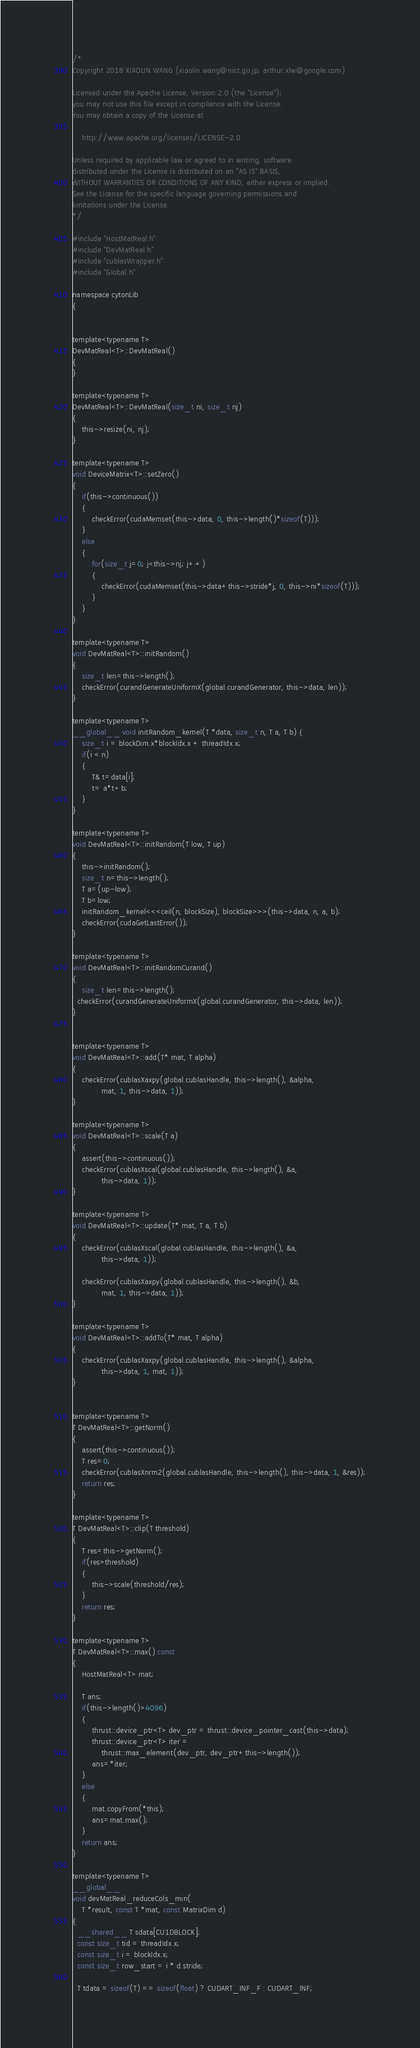<code> <loc_0><loc_0><loc_500><loc_500><_Cuda_>/*
Copyright 2018 XIAOLIN WANG (xiaolin.wang@nict.go.jp; arthur.xlw@google.com)

Licensed under the Apache License, Version 2.0 (the "License");
you may not use this file except in compliance with the License.
You may obtain a copy of the License at

    http://www.apache.org/licenses/LICENSE-2.0

Unless required by applicable law or agreed to in writing, software
distributed under the License is distributed on an "AS IS" BASIS,
WITHOUT WARRANTIES OR CONDITIONS OF ANY KIND, either express or implied.
See the License for the specific language governing permissions and
limitations under the License.
*/

#include "HostMatReal.h"
#include "DevMatReal.h"
#include "cublasWrapper.h"
#include "Global.h"

namespace cytonLib
{


template<typename T>
DevMatReal<T>::DevMatReal()
{
}

template<typename T>
DevMatReal<T>::DevMatReal(size_t ni, size_t nj)
{
	this->resize(ni, nj);
}

template<typename T>
void DeviceMatrix<T>::setZero()
{
	if(this->continuous())
	{
		checkError(cudaMemset(this->data, 0, this->length()*sizeof(T)));
	}
	else
	{
		for(size_t j=0; j<this->nj; j++)
		{
			checkError(cudaMemset(this->data+this->stride*j, 0, this->ni*sizeof(T)));
		}
	}
}

template<typename T>
void DevMatReal<T>::initRandom()
{
	size_t len=this->length();
    checkError(curandGenerateUniformX(global.curandGenerator, this->data, len));
}

template<typename T>
__global__ void initRandom_kernel(T *data, size_t n, T a, T b) {
    size_t i = blockDim.x*blockIdx.x + threadIdx.x;
    if(i < n)
    {
    	T& t=data[i];
    	t= a*t+b;
    }
}

template<typename T>
void DevMatReal<T>::initRandom(T low, T up)
{
	this->initRandom();
	size_t n=this->length();
	T a=(up-low);
	T b=low;
	initRandom_kernel<<<ceil(n, blockSize), blockSize>>>(this->data, n, a, b);
	checkError(cudaGetLastError());
}

template<typename T>
void DevMatReal<T>::initRandomCurand()
{
	size_t len=this->length();
  checkError(curandGenerateUniformX(global.curandGenerator, this->data, len));
}


template<typename T>
void DevMatReal<T>::add(T* mat, T alpha)
{
	checkError(cublasXaxpy(global.cublasHandle, this->length(), &alpha,
			mat, 1, this->data, 1));
}

template<typename T>
void DevMatReal<T>::scale(T a)
{
	assert(this->continuous());
	checkError(cublasXscal(global.cublasHandle, this->length(), &a,
			this->data, 1));
}

template<typename T>
void DevMatReal<T>::update(T* mat, T a, T b)
{
	checkError(cublasXscal(global.cublasHandle, this->length(), &a,
			this->data, 1));

	checkError(cublasXaxpy(global.cublasHandle, this->length(), &b,
			mat, 1, this->data, 1));
}

template<typename T>
void DevMatReal<T>::addTo(T* mat, T alpha)
{
	checkError(cublasXaxpy(global.cublasHandle, this->length(), &alpha,
			this->data, 1, mat, 1));
}


template<typename T>
T DevMatReal<T>::getNorm()
{
	assert(this->continuous());
	T res=0;
	checkError(cublasXnrm2(global.cublasHandle, this->length(), this->data, 1, &res));
	return res;
}

template<typename T>
T DevMatReal<T>::clip(T threshold)
{
	T res=this->getNorm();
	if(res>threshold)
	{
		this->scale(threshold/res);
	}
	return res;
}

template<typename T>
T DevMatReal<T>::max() const
{
	HostMatReal<T> mat;

	T ans;
	if(this->length()>4096)
	{
		thrust::device_ptr<T> dev_ptr = thrust::device_pointer_cast(this->data);
		thrust::device_ptr<T> iter =
			thrust::max_element(dev_ptr, dev_ptr+this->length());
		ans=*iter;
	}
	else
	{
		mat.copyFrom(*this);
		ans=mat.max();
	}
	return ans;
}

template<typename T>
__global__
void devMatReal_reduceCols_min(
    T *result, const T *mat, const MatrixDim d)
{
  __shared__ T sdata[CU1DBLOCK];
  const size_t tid = threadIdx.x;
  const size_t i = blockIdx.x;
  const size_t row_start = i * d.stride;

  T tdata = sizeof(T) == sizeof(float) ? CUDART_INF_F : CUDART_INF;</code> 